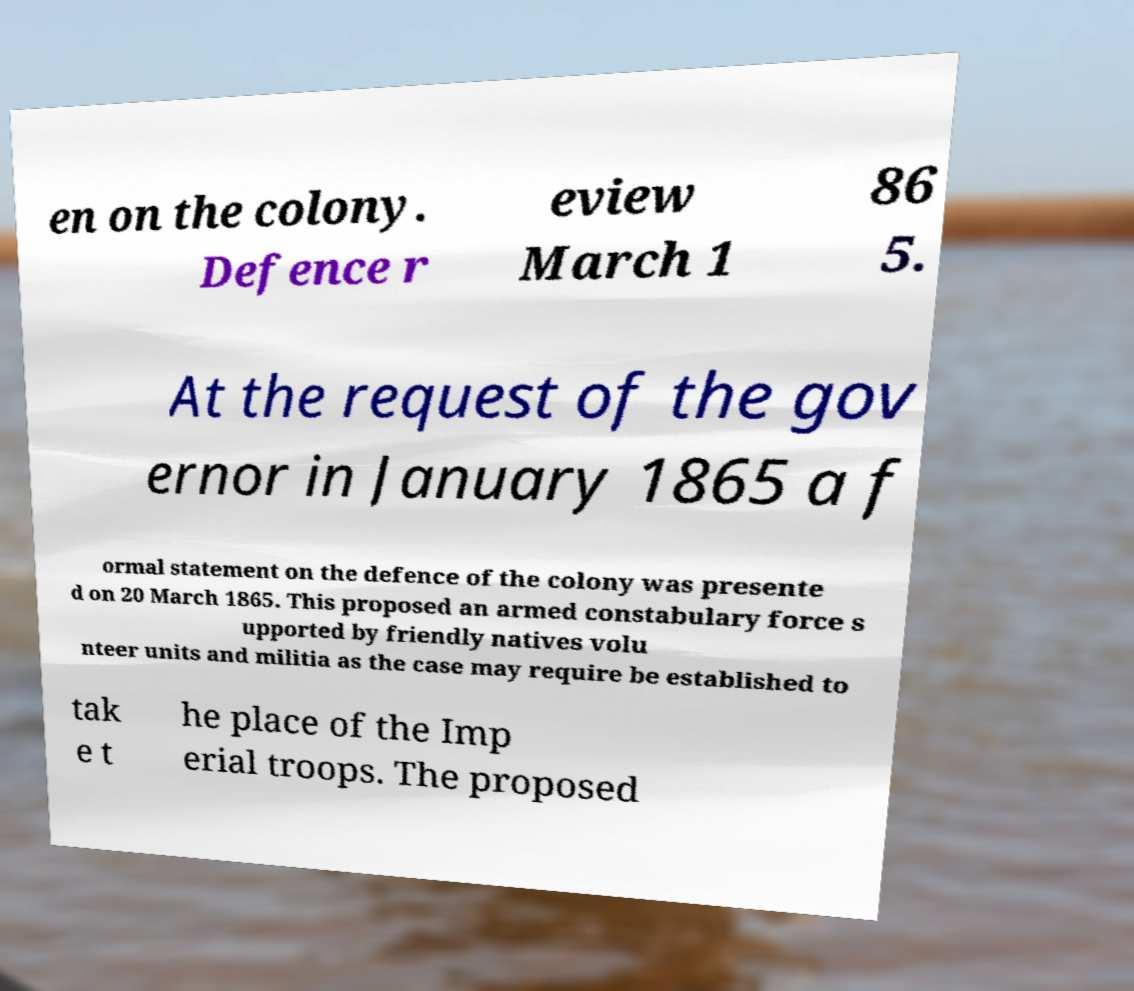I need the written content from this picture converted into text. Can you do that? en on the colony. Defence r eview March 1 86 5. At the request of the gov ernor in January 1865 a f ormal statement on the defence of the colony was presente d on 20 March 1865. This proposed an armed constabulary force s upported by friendly natives volu nteer units and militia as the case may require be established to tak e t he place of the Imp erial troops. The proposed 